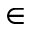Convert formula to latex. <formula><loc_0><loc_0><loc_500><loc_500>\in</formula> 